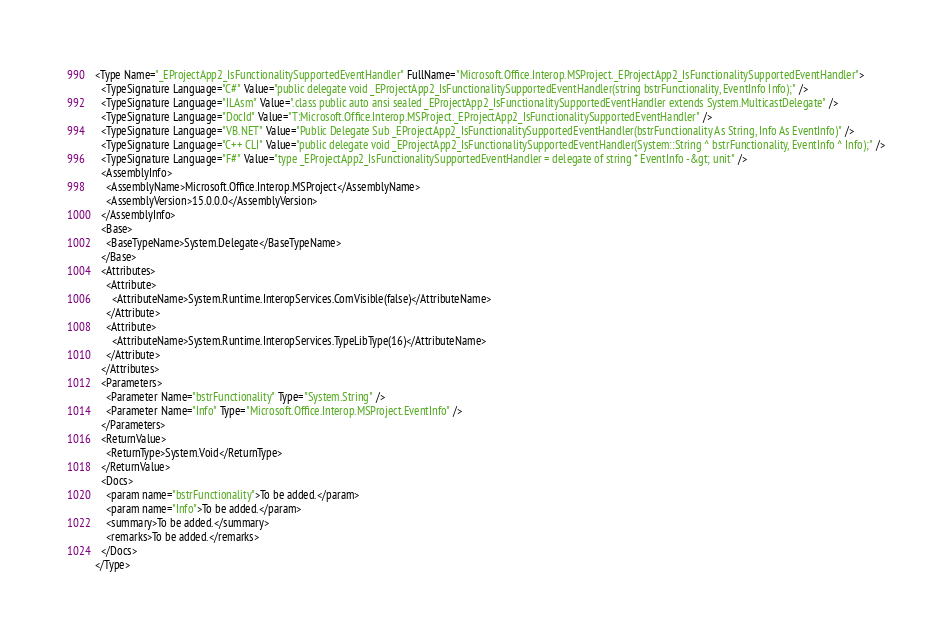Convert code to text. <code><loc_0><loc_0><loc_500><loc_500><_XML_><Type Name="_EProjectApp2_IsFunctionalitySupportedEventHandler" FullName="Microsoft.Office.Interop.MSProject._EProjectApp2_IsFunctionalitySupportedEventHandler">
  <TypeSignature Language="C#" Value="public delegate void _EProjectApp2_IsFunctionalitySupportedEventHandler(string bstrFunctionality, EventInfo Info);" />
  <TypeSignature Language="ILAsm" Value=".class public auto ansi sealed _EProjectApp2_IsFunctionalitySupportedEventHandler extends System.MulticastDelegate" />
  <TypeSignature Language="DocId" Value="T:Microsoft.Office.Interop.MSProject._EProjectApp2_IsFunctionalitySupportedEventHandler" />
  <TypeSignature Language="VB.NET" Value="Public Delegate Sub _EProjectApp2_IsFunctionalitySupportedEventHandler(bstrFunctionality As String, Info As EventInfo)" />
  <TypeSignature Language="C++ CLI" Value="public delegate void _EProjectApp2_IsFunctionalitySupportedEventHandler(System::String ^ bstrFunctionality, EventInfo ^ Info);" />
  <TypeSignature Language="F#" Value="type _EProjectApp2_IsFunctionalitySupportedEventHandler = delegate of string * EventInfo -&gt; unit" />
  <AssemblyInfo>
    <AssemblyName>Microsoft.Office.Interop.MSProject</AssemblyName>
    <AssemblyVersion>15.0.0.0</AssemblyVersion>
  </AssemblyInfo>
  <Base>
    <BaseTypeName>System.Delegate</BaseTypeName>
  </Base>
  <Attributes>
    <Attribute>
      <AttributeName>System.Runtime.InteropServices.ComVisible(false)</AttributeName>
    </Attribute>
    <Attribute>
      <AttributeName>System.Runtime.InteropServices.TypeLibType(16)</AttributeName>
    </Attribute>
  </Attributes>
  <Parameters>
    <Parameter Name="bstrFunctionality" Type="System.String" />
    <Parameter Name="Info" Type="Microsoft.Office.Interop.MSProject.EventInfo" />
  </Parameters>
  <ReturnValue>
    <ReturnType>System.Void</ReturnType>
  </ReturnValue>
  <Docs>
    <param name="bstrFunctionality">To be added.</param>
    <param name="Info">To be added.</param>
    <summary>To be added.</summary>
    <remarks>To be added.</remarks>
  </Docs>
</Type>
</code> 